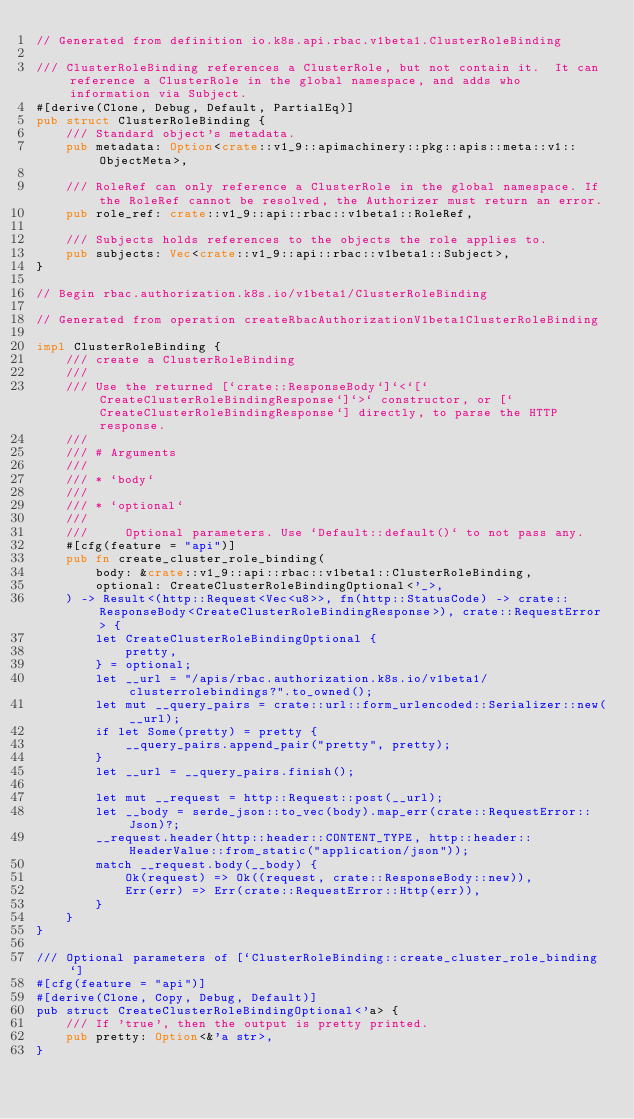<code> <loc_0><loc_0><loc_500><loc_500><_Rust_>// Generated from definition io.k8s.api.rbac.v1beta1.ClusterRoleBinding

/// ClusterRoleBinding references a ClusterRole, but not contain it.  It can reference a ClusterRole in the global namespace, and adds who information via Subject.
#[derive(Clone, Debug, Default, PartialEq)]
pub struct ClusterRoleBinding {
    /// Standard object's metadata.
    pub metadata: Option<crate::v1_9::apimachinery::pkg::apis::meta::v1::ObjectMeta>,

    /// RoleRef can only reference a ClusterRole in the global namespace. If the RoleRef cannot be resolved, the Authorizer must return an error.
    pub role_ref: crate::v1_9::api::rbac::v1beta1::RoleRef,

    /// Subjects holds references to the objects the role applies to.
    pub subjects: Vec<crate::v1_9::api::rbac::v1beta1::Subject>,
}

// Begin rbac.authorization.k8s.io/v1beta1/ClusterRoleBinding

// Generated from operation createRbacAuthorizationV1beta1ClusterRoleBinding

impl ClusterRoleBinding {
    /// create a ClusterRoleBinding
    ///
    /// Use the returned [`crate::ResponseBody`]`<`[`CreateClusterRoleBindingResponse`]`>` constructor, or [`CreateClusterRoleBindingResponse`] directly, to parse the HTTP response.
    ///
    /// # Arguments
    ///
    /// * `body`
    ///
    /// * `optional`
    ///
    ///     Optional parameters. Use `Default::default()` to not pass any.
    #[cfg(feature = "api")]
    pub fn create_cluster_role_binding(
        body: &crate::v1_9::api::rbac::v1beta1::ClusterRoleBinding,
        optional: CreateClusterRoleBindingOptional<'_>,
    ) -> Result<(http::Request<Vec<u8>>, fn(http::StatusCode) -> crate::ResponseBody<CreateClusterRoleBindingResponse>), crate::RequestError> {
        let CreateClusterRoleBindingOptional {
            pretty,
        } = optional;
        let __url = "/apis/rbac.authorization.k8s.io/v1beta1/clusterrolebindings?".to_owned();
        let mut __query_pairs = crate::url::form_urlencoded::Serializer::new(__url);
        if let Some(pretty) = pretty {
            __query_pairs.append_pair("pretty", pretty);
        }
        let __url = __query_pairs.finish();

        let mut __request = http::Request::post(__url);
        let __body = serde_json::to_vec(body).map_err(crate::RequestError::Json)?;
        __request.header(http::header::CONTENT_TYPE, http::header::HeaderValue::from_static("application/json"));
        match __request.body(__body) {
            Ok(request) => Ok((request, crate::ResponseBody::new)),
            Err(err) => Err(crate::RequestError::Http(err)),
        }
    }
}

/// Optional parameters of [`ClusterRoleBinding::create_cluster_role_binding`]
#[cfg(feature = "api")]
#[derive(Clone, Copy, Debug, Default)]
pub struct CreateClusterRoleBindingOptional<'a> {
    /// If 'true', then the output is pretty printed.
    pub pretty: Option<&'a str>,
}
</code> 